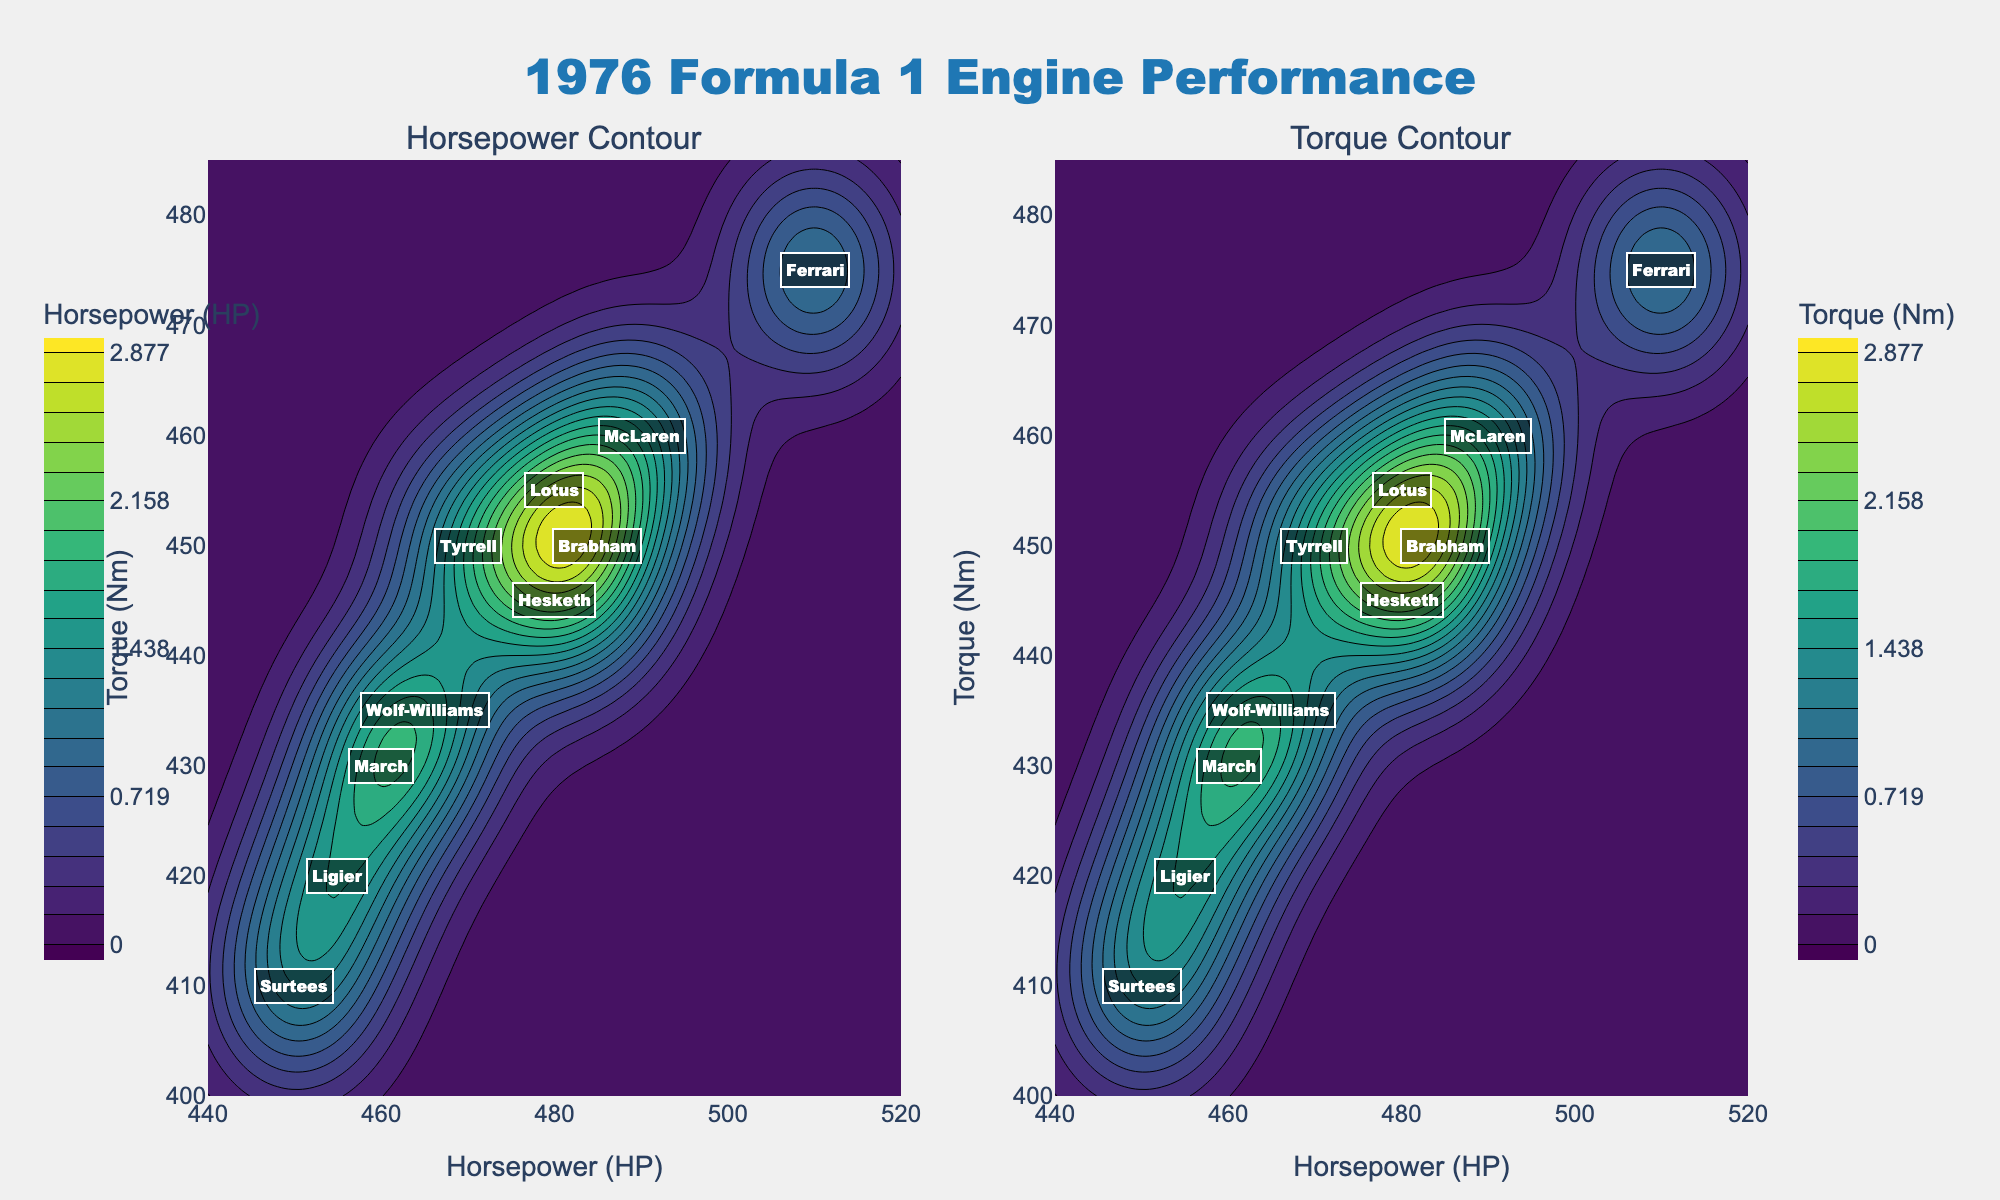What's the title of the figure? The title is located at the top center of the figure and usually provides an overview of what the figure represents.
Answer: 1976 Formula 1 Engine Performance What are the units for the x-axis in both subplots? The x-axis units can be determined by looking at the axis label on both subplots.
Answer: Horsepower (HP) How many constructors are labeled in the plot? By counting the number of unique annotations or labels in the contour plots, we reach the answer.
Answer: 10 Which constructor has the highest combination of horsepower and torque? By looking at the highest values along both the x and y axes and identifying the corresponding label, we determine the constructor. In this case, Ferrari has the highest combination of 510 HP and 475 Nm torque.
Answer: Ferrari Based on the horsepower contour, what range of horsepower values is most densely populated? We need to observe the regions with the highest concentration of contour lines in the Horsepower Contour subplot. Typically, a high density of contour lines indicates higher population.
Answer: Approximately 450-490 HP Which constructor is located closest to 460 HP and 430 Nm torque? By finding the point on the contour plot closest to the coordinates (460, 430) and noting the corresponding label, we can identify the constructor.
Answer: March Compare the torque values for Ferrari and McLaren. Which has a higher torque and by how much? Look at the y-axis values for Ferrari and McLaren and calculate the difference. Ferrari has 475 Nm, McLaren has 460 Nm. The difference is 475 - 460.
Answer: Ferrari by 15 Nm Which constructors have a torque value below 440 Nm? By looking at the y-axis values and identifying the constructors whose torque values are below 440 Nm, we gather this information.
Answer: Ligier, Surtees, Hesketh, Wolf-Williams What is the average torque value for all constructors? Add up all the torque values and then divide by the number of constructors. The values are: (475 + 460 + 450 + 455 + 450 + 430 + 420 + 410 + 445 + 435). Sum = 4430, Average = 4430 / 10.
Answer: 443 Nm Is there any constructor in the figure that has the same horsepower and torque values? Verify by checking if any constructors have the same x (Horsepower) and y (Torque) values. If none, then no constructor shares identical values.
Answer: No 